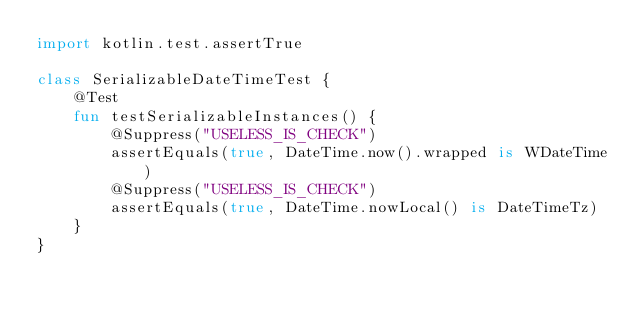Convert code to text. <code><loc_0><loc_0><loc_500><loc_500><_Kotlin_>import kotlin.test.assertTrue

class SerializableDateTimeTest {
	@Test
	fun testSerializableInstances() {
		@Suppress("USELESS_IS_CHECK")
		assertEquals(true, DateTime.now().wrapped is WDateTime)
		@Suppress("USELESS_IS_CHECK")
		assertEquals(true, DateTime.nowLocal() is DateTimeTz)
	}
}
</code> 